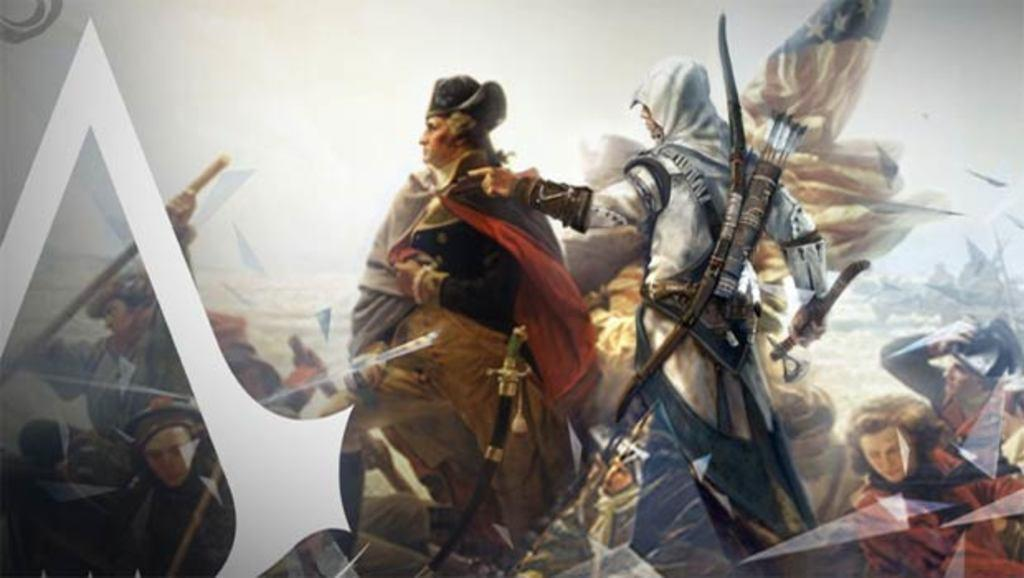Who is present in the image? There are people in the image. What are the people holding in the image? The people are carrying weapons. What can be inferred about the setting of the image? The image appears to be set in a war scene. What language are the people speaking in the image? The provided facts do not mention any specific language being spoken in the image. --- Facts: 1. There is a car in the image. 2. The car is parked on the side of the road. 3. There are trees in the background of the image. 4. The sky is visible in the image. Absurd Topics: dance, ocean, animal Conversation: What is the main subject of the image? The main subject of the image is a car. Where is the car located in the image? The car is parked on the side of the road. What can be seen in the background of the image? There are trees in the background of the image. What is visible at the top of the image? The sky is visible in the image. Reasoning: Let's think step by step in order to produce the conversation. We start by identifying the main subject of the image, which is the car. Then, we describe the car's location, which is parked on the side of the road. Next, we mention the background elements, which include trees. Finally, we describe the sky, which is visible at the top of the image. Absurd Question/Answer: Can you see any animals in the image? There are no animals present in the image; it features a parked car on the side of the road with trees and the sky visible in the background. --- Facts: 1. There is a person in the image. 2. The person is wearing a hat. 3. The person is holding a book. 4. There is a table in the image. 5. The table has a lamp on it. Absurd Topics: bicycle, parrot, umbrella Conversation: Who is present in the image? There is a person in the image. What is the person wearing? The person is wearing a hat. What is the person holding? The person is holding a book. What can be seen on the table in the image? There is a table in the image, and it has a lamp on it. Reasoning: Let's think step by step in order to produce the conversation. We start by identifying the main subject of the image, which is the person. Then, we describe the person's attire, specifically mentioning the hat. Next, we observe what the person is holding, which is a book. Finally, we describe the objects on the table, which include a lamp. Absurd Question/Answer: Can you see a bicycle in the image? No, there is no bicycle present in the 